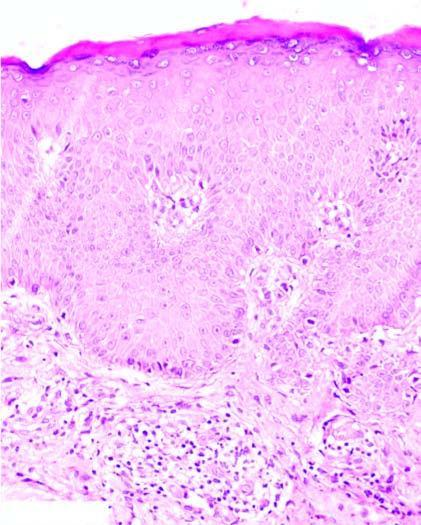what shows mild perivascular chronic inflammatory cell infiltrate?
Answer the question using a single word or phrase. Dermis 